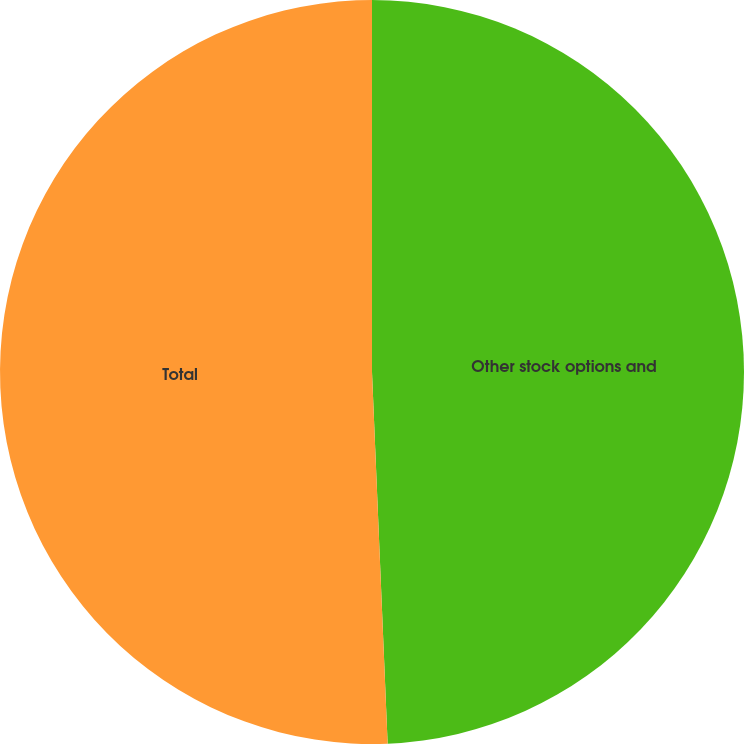Convert chart. <chart><loc_0><loc_0><loc_500><loc_500><pie_chart><fcel>Other stock options and<fcel>Total<nl><fcel>49.33%<fcel>50.67%<nl></chart> 